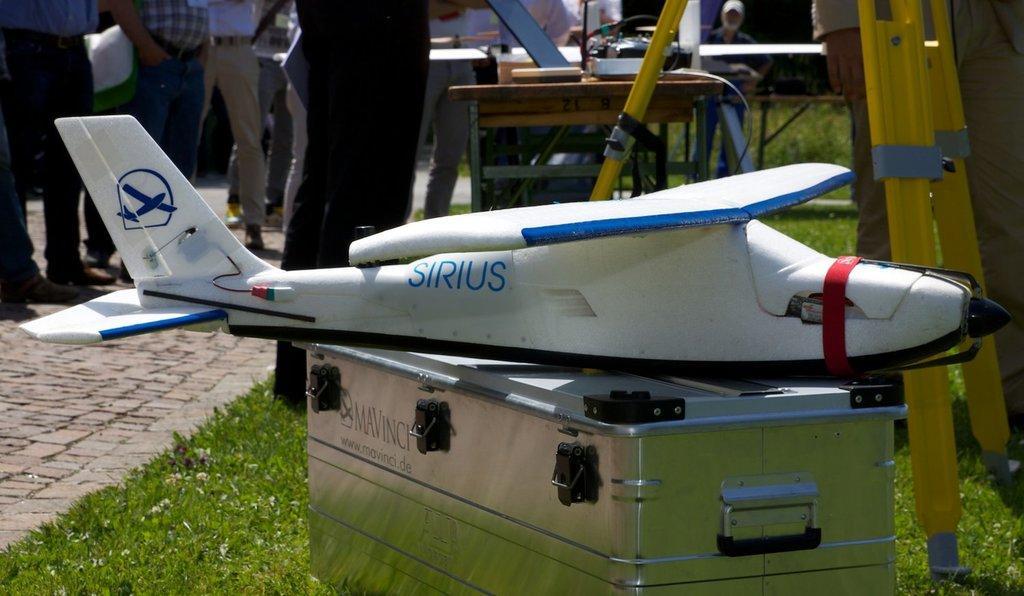Please provide a concise description of this image. In the image we can see there is an aeroplane toy kept on the iron box and there are tables kept on the ground. The ground is covered with grass and behind there are other people standing on the footpath. 